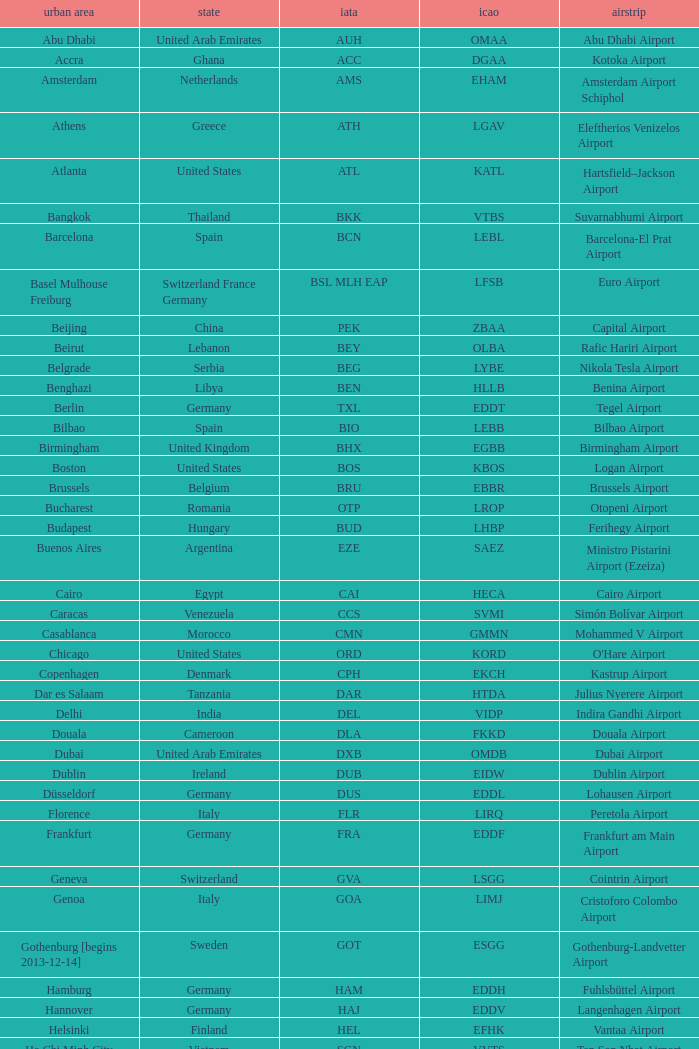What is the IATA for Ringway Airport in the United Kingdom? MAN. 